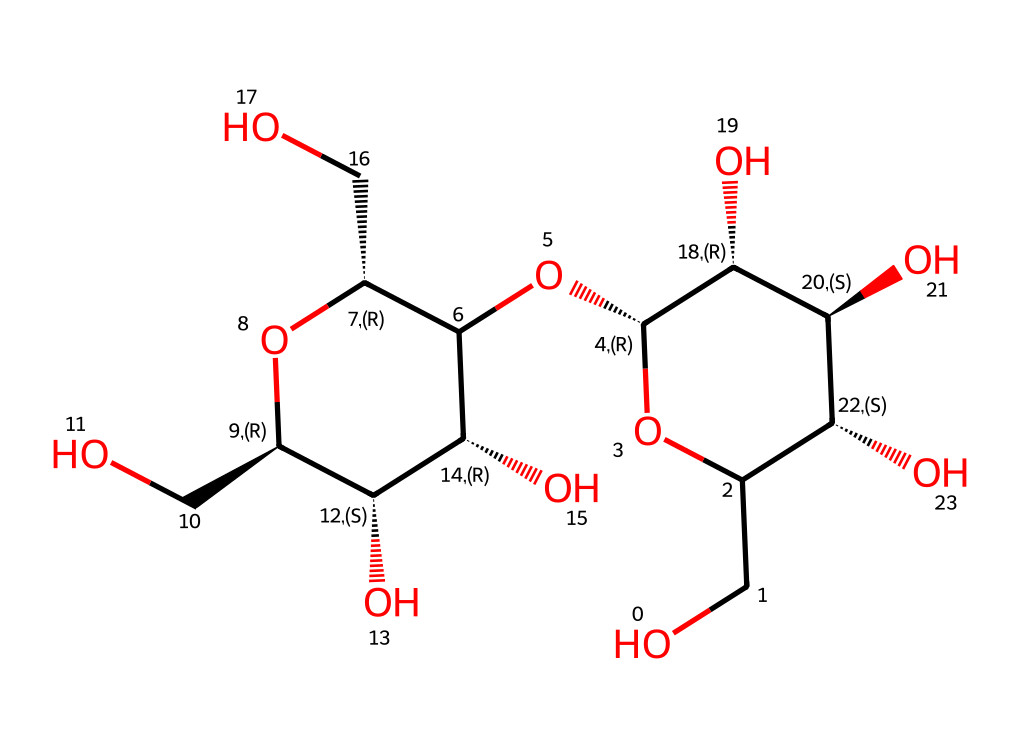What is the molecular formula of cellulose represented by this SMILES? By analyzing the SMILES representation, we can count all the atoms present. In this structure, there are 6 carbon atoms (C), 10 hydrogen atoms (H), and 5 oxygen atoms (O), leading to the molecular formula C6H10O5, which corresponds to the repeating unit of cellulose.
Answer: C6H10O5 How many hydroxyl (–OH) groups are present in this structure? The structure contains several –OH groups. By examining the SMILES notation, we can identify the number of hydroxyl groups that are directly attached to carbon atoms in the chain. There are 3 distinct –OH groups in the depiction.
Answer: 3 What type of polysaccharide is cellulose? Cellulose is known for its structural role in plant cell walls. Observing the repeating glucose units and the beta-glycosidic bonds indicates that this polysaccharide functions primarily in providing structural support rather than energy storage.
Answer: structural Which type of linkages are present in cellulose? Cellulose is characterized by beta-1,4-glycosidic linkages between glucose units. By examining the connected glucose structure in the SMILES, we can confirm the presence of these specific linkages that differentiate cellulose from other sugars.
Answer: beta-1,4-glycosidic What is the degree of polymerization for a single cellulose chain represented by this SMILES? The number of glucose units in cellulose can determine its degree of polymerization. In this specific depiction of cellulose, there are typically 3 to 4 repeating glucose units represented in the chain portion of the SMILES.
Answer: 4 How does cellulose contribute to the strength of wooden structures? The arrangement and bonding of the cellulose fibers (beta linkages) provide high tensile strength, making them integral to the structural integrity of wood. This is due to the rigid arrangement in the chains and bonding between the fibers, enhancing their mechanical properties and supporting structures.
Answer: tensile strength 